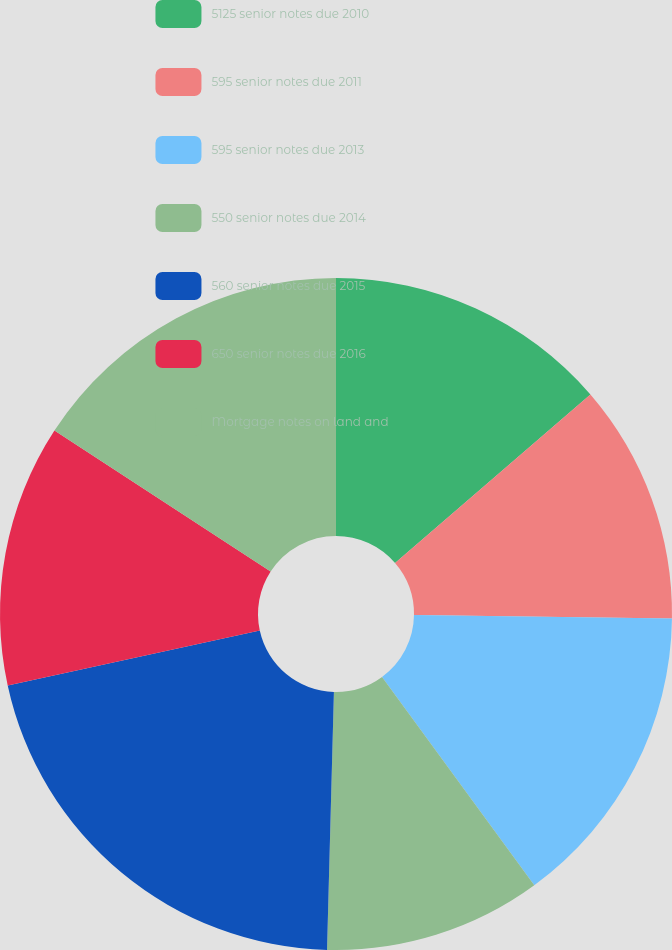Convert chart to OTSL. <chart><loc_0><loc_0><loc_500><loc_500><pie_chart><fcel>5125 senior notes due 2010<fcel>595 senior notes due 2011<fcel>595 senior notes due 2013<fcel>550 senior notes due 2014<fcel>560 senior notes due 2015<fcel>650 senior notes due 2016<fcel>Mortgage notes on land and<nl><fcel>13.67%<fcel>11.54%<fcel>14.74%<fcel>10.47%<fcel>21.16%<fcel>12.6%<fcel>15.81%<nl></chart> 